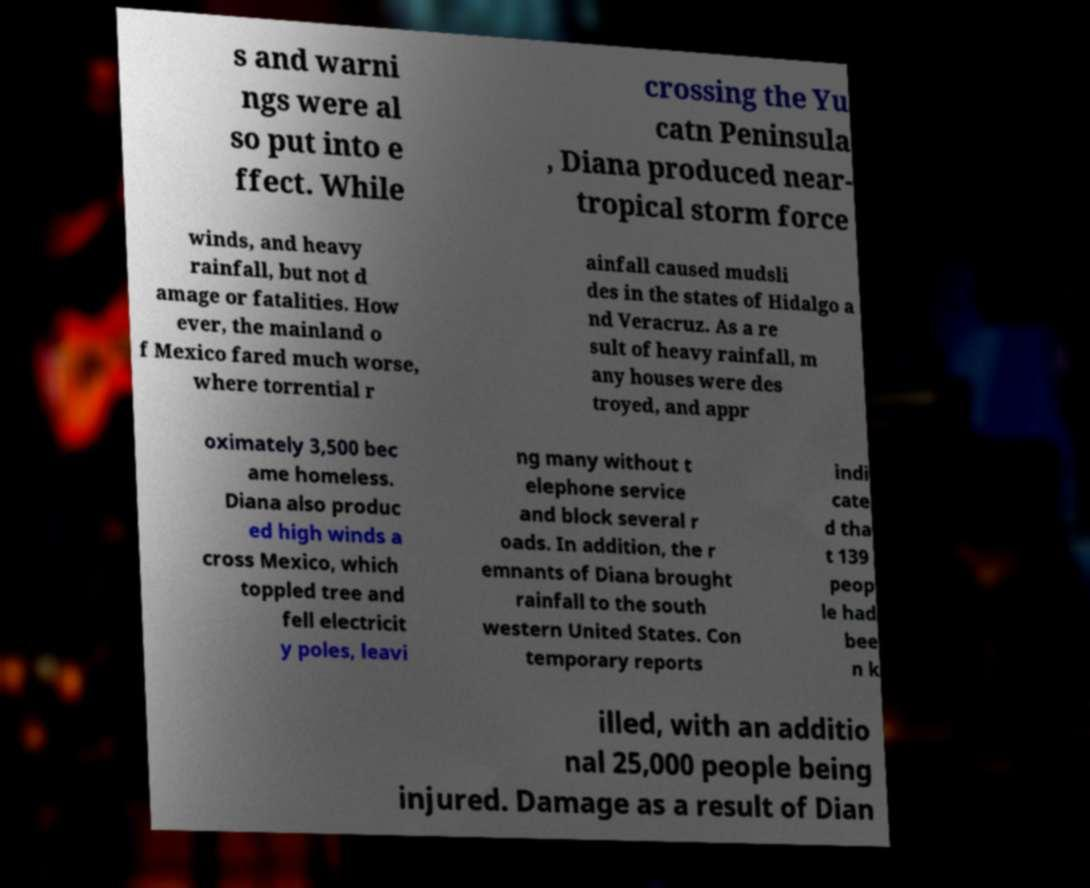There's text embedded in this image that I need extracted. Can you transcribe it verbatim? s and warni ngs were al so put into e ffect. While crossing the Yu catn Peninsula , Diana produced near- tropical storm force winds, and heavy rainfall, but not d amage or fatalities. How ever, the mainland o f Mexico fared much worse, where torrential r ainfall caused mudsli des in the states of Hidalgo a nd Veracruz. As a re sult of heavy rainfall, m any houses were des troyed, and appr oximately 3,500 bec ame homeless. Diana also produc ed high winds a cross Mexico, which toppled tree and fell electricit y poles, leavi ng many without t elephone service and block several r oads. In addition, the r emnants of Diana brought rainfall to the south western United States. Con temporary reports indi cate d tha t 139 peop le had bee n k illed, with an additio nal 25,000 people being injured. Damage as a result of Dian 